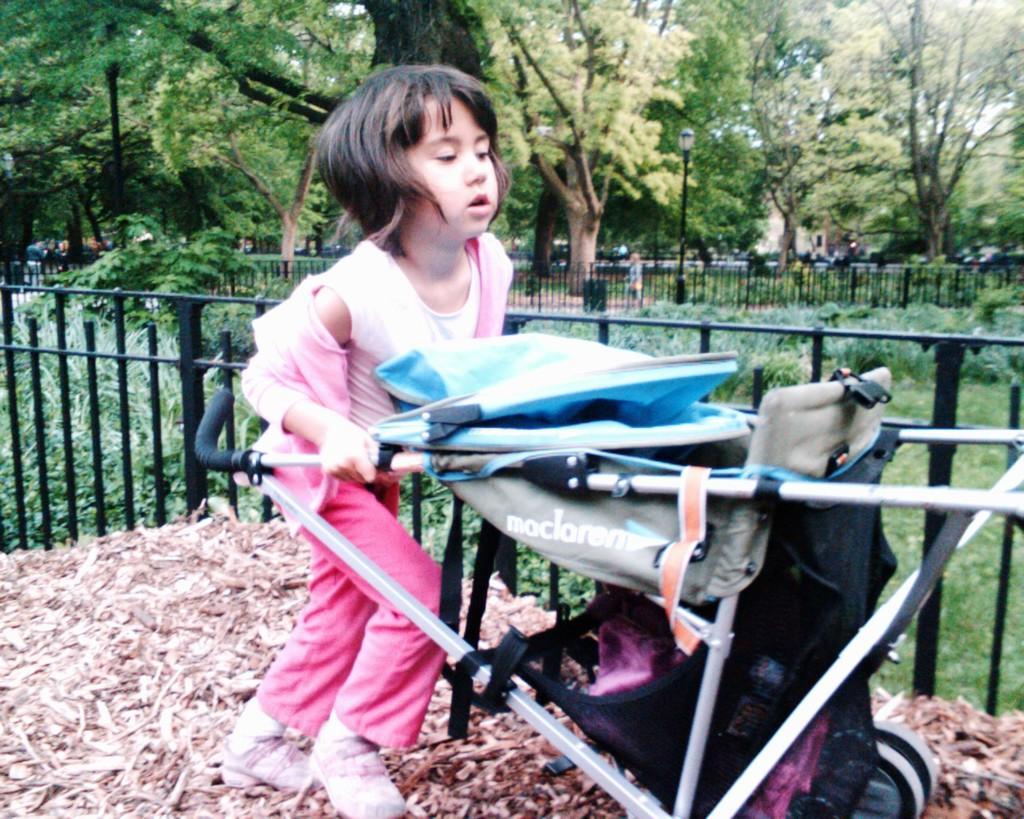How would you summarize this image in a sentence or two? In this image we can see a girl is pushing stroller with her hands. In the background we can see fences, plants, trees, a person is standing on the ground, building and sky. 